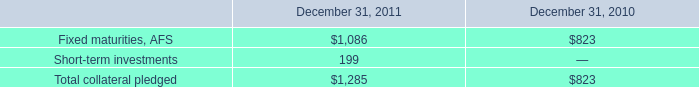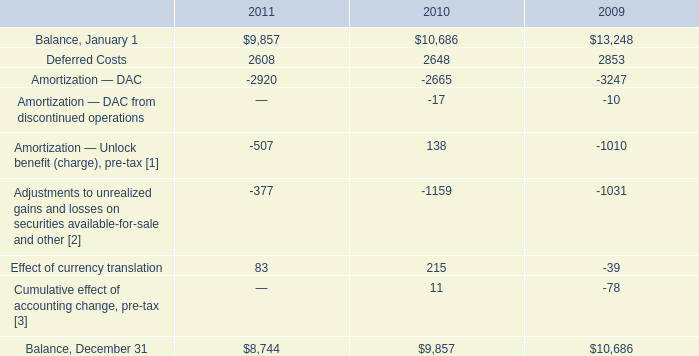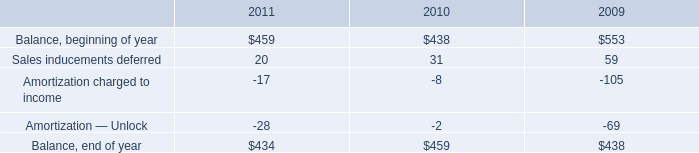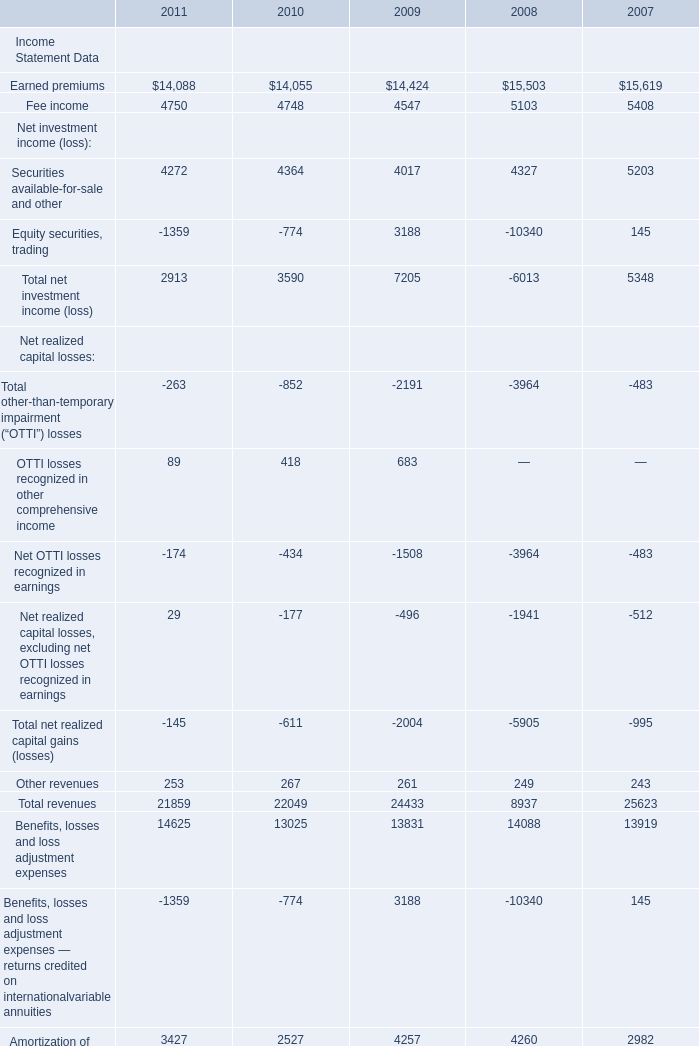What's the average of Balance, January 1 of 2011, and Earned premiums of 2010 ? 
Computations: ((9857.0 + 14055.0) / 2)
Answer: 11956.0. 